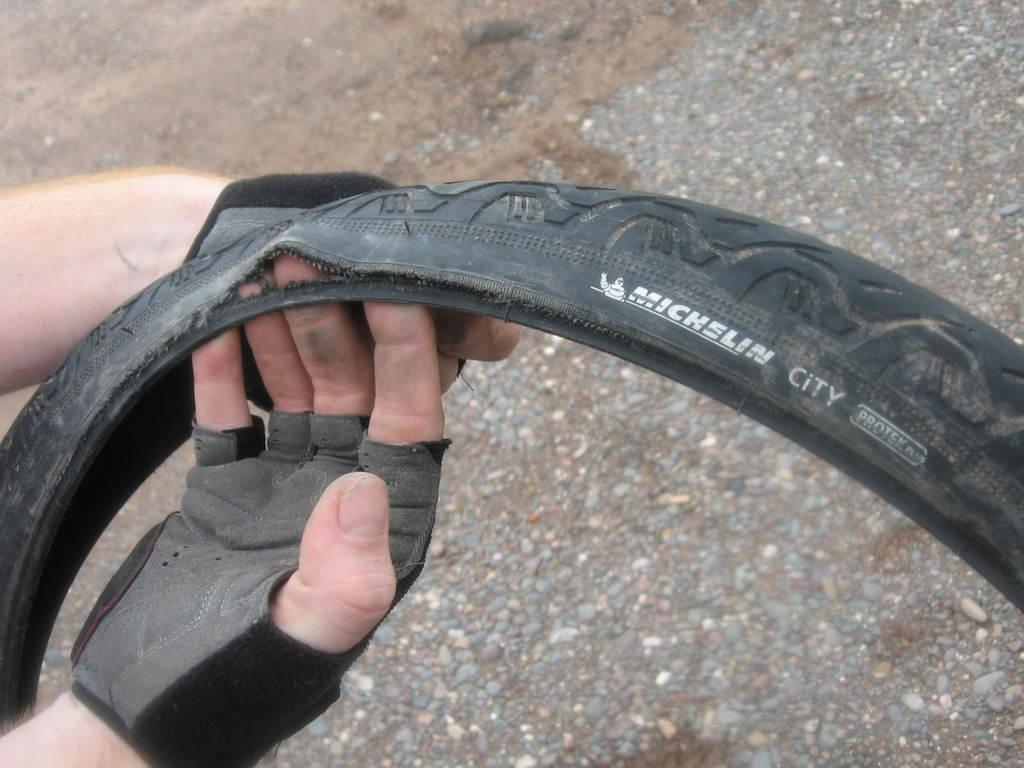What is present in the image? There is a person in the image. What is the person wearing? The person is wearing gloves. What is the person holding? The person is holding a tie. What can be seen at the bottom of the image? There is ground visible at the bottom of the image. Is there any glue visible on the tie in the image? There is no glue present in the image. How does the person stop the tie from moving in the image? The person is holding the tie, but there is no indication of any action to stop it from moving in the image. 